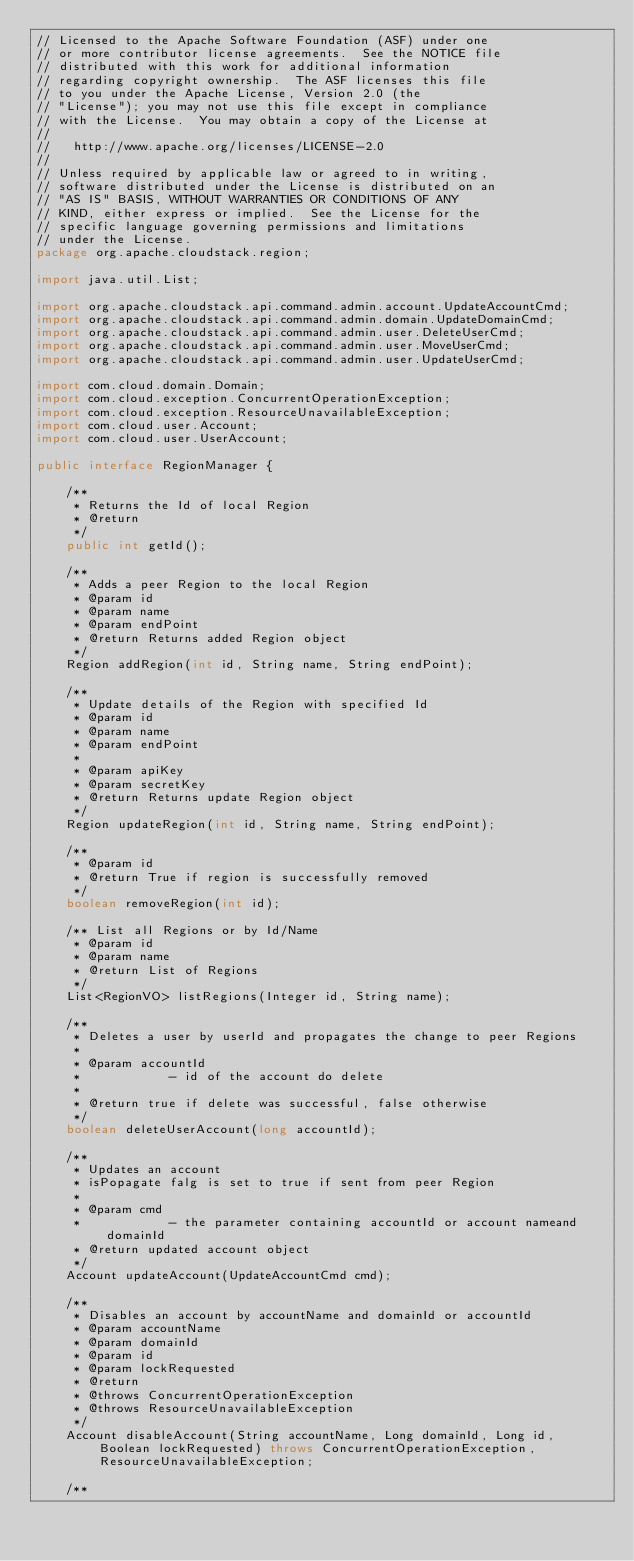<code> <loc_0><loc_0><loc_500><loc_500><_Java_>// Licensed to the Apache Software Foundation (ASF) under one
// or more contributor license agreements.  See the NOTICE file
// distributed with this work for additional information
// regarding copyright ownership.  The ASF licenses this file
// to you under the Apache License, Version 2.0 (the
// "License"); you may not use this file except in compliance
// with the License.  You may obtain a copy of the License at
//
//   http://www.apache.org/licenses/LICENSE-2.0
//
// Unless required by applicable law or agreed to in writing,
// software distributed under the License is distributed on an
// "AS IS" BASIS, WITHOUT WARRANTIES OR CONDITIONS OF ANY
// KIND, either express or implied.  See the License for the
// specific language governing permissions and limitations
// under the License.
package org.apache.cloudstack.region;

import java.util.List;

import org.apache.cloudstack.api.command.admin.account.UpdateAccountCmd;
import org.apache.cloudstack.api.command.admin.domain.UpdateDomainCmd;
import org.apache.cloudstack.api.command.admin.user.DeleteUserCmd;
import org.apache.cloudstack.api.command.admin.user.MoveUserCmd;
import org.apache.cloudstack.api.command.admin.user.UpdateUserCmd;

import com.cloud.domain.Domain;
import com.cloud.exception.ConcurrentOperationException;
import com.cloud.exception.ResourceUnavailableException;
import com.cloud.user.Account;
import com.cloud.user.UserAccount;

public interface RegionManager {

    /**
     * Returns the Id of local Region
     * @return
     */
    public int getId();

    /**
     * Adds a peer Region to the local Region
     * @param id
     * @param name
     * @param endPoint
     * @return Returns added Region object
     */
    Region addRegion(int id, String name, String endPoint);

    /**
     * Update details of the Region with specified Id
     * @param id
     * @param name
     * @param endPoint
     *
     * @param apiKey
     * @param secretKey
     * @return Returns update Region object
     */
    Region updateRegion(int id, String name, String endPoint);

    /**
     * @param id
     * @return True if region is successfully removed
     */
    boolean removeRegion(int id);

    /** List all Regions or by Id/Name
     * @param id
     * @param name
     * @return List of Regions
     */
    List<RegionVO> listRegions(Integer id, String name);

    /**
     * Deletes a user by userId and propagates the change to peer Regions
     *
     * @param accountId
     *            - id of the account do delete
     *
     * @return true if delete was successful, false otherwise
     */
    boolean deleteUserAccount(long accountId);

    /**
     * Updates an account
     * isPopagate falg is set to true if sent from peer Region
     *
     * @param cmd
     *            - the parameter containing accountId or account nameand domainId
     * @return updated account object
     */
    Account updateAccount(UpdateAccountCmd cmd);

    /**
     * Disables an account by accountName and domainId or accountId
     * @param accountName
     * @param domainId
     * @param id
     * @param lockRequested
     * @return
     * @throws ConcurrentOperationException
     * @throws ResourceUnavailableException
     */
    Account disableAccount(String accountName, Long domainId, Long id, Boolean lockRequested) throws ConcurrentOperationException, ResourceUnavailableException;

    /**</code> 